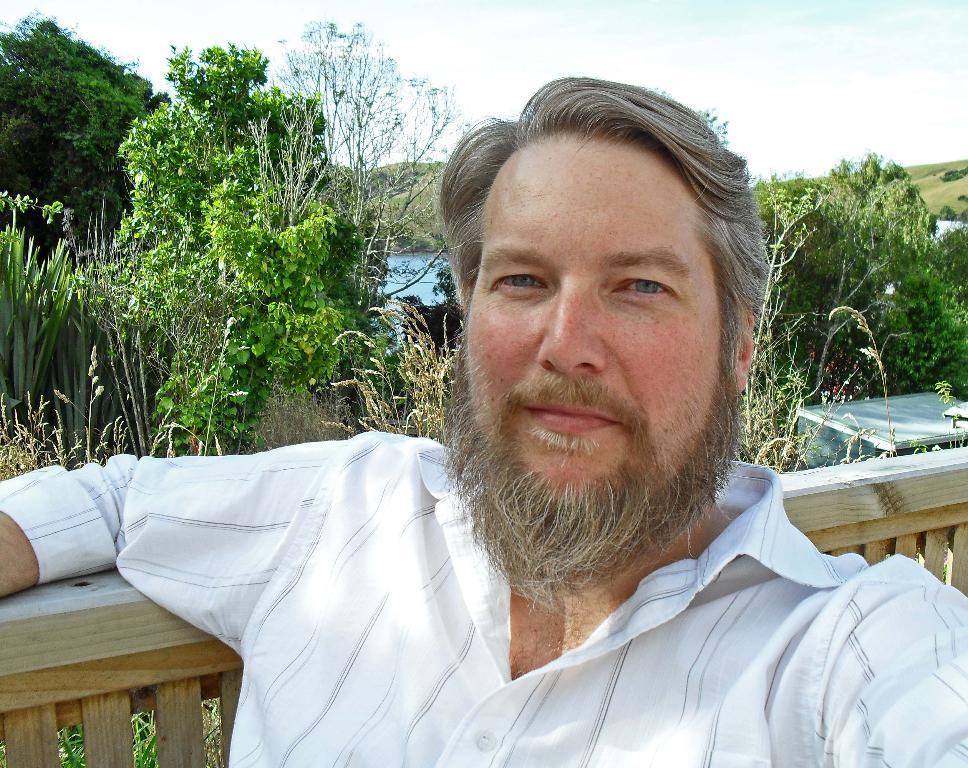How would you summarize this image in a sentence or two? A person is present wearing a white shirt. Behind him there is a wooden fencing. There are trees and water at the back. 